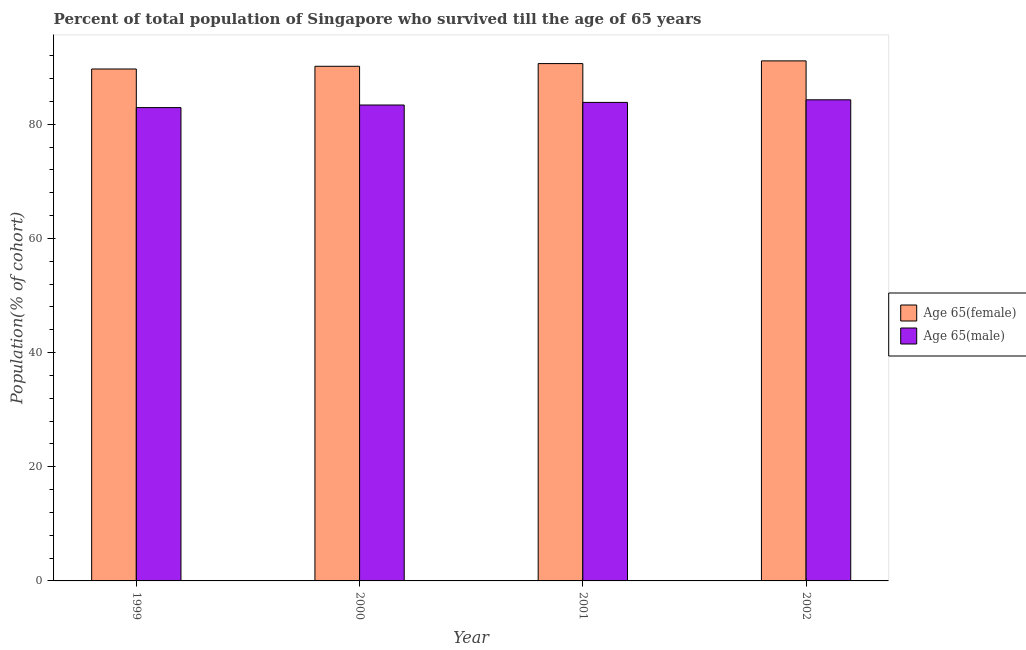How many different coloured bars are there?
Your answer should be very brief. 2. Are the number of bars on each tick of the X-axis equal?
Give a very brief answer. Yes. What is the label of the 3rd group of bars from the left?
Give a very brief answer. 2001. In how many cases, is the number of bars for a given year not equal to the number of legend labels?
Give a very brief answer. 0. What is the percentage of male population who survived till age of 65 in 2001?
Offer a terse response. 83.84. Across all years, what is the maximum percentage of female population who survived till age of 65?
Provide a short and direct response. 91.11. Across all years, what is the minimum percentage of male population who survived till age of 65?
Provide a succinct answer. 82.93. In which year was the percentage of male population who survived till age of 65 maximum?
Keep it short and to the point. 2002. What is the total percentage of female population who survived till age of 65 in the graph?
Offer a very short reply. 361.6. What is the difference between the percentage of female population who survived till age of 65 in 2001 and that in 2002?
Your answer should be very brief. -0.47. What is the difference between the percentage of male population who survived till age of 65 in 2001 and the percentage of female population who survived till age of 65 in 2002?
Your answer should be compact. -0.45. What is the average percentage of male population who survived till age of 65 per year?
Offer a terse response. 83.61. What is the ratio of the percentage of male population who survived till age of 65 in 1999 to that in 2000?
Offer a very short reply. 0.99. Is the difference between the percentage of female population who survived till age of 65 in 1999 and 2000 greater than the difference between the percentage of male population who survived till age of 65 in 1999 and 2000?
Your answer should be compact. No. What is the difference between the highest and the second highest percentage of male population who survived till age of 65?
Give a very brief answer. 0.45. What is the difference between the highest and the lowest percentage of female population who survived till age of 65?
Give a very brief answer. 1.42. What does the 1st bar from the left in 2001 represents?
Your answer should be compact. Age 65(female). What does the 2nd bar from the right in 2002 represents?
Offer a very short reply. Age 65(female). How many bars are there?
Your answer should be compact. 8. How many years are there in the graph?
Your answer should be very brief. 4. Does the graph contain any zero values?
Your answer should be very brief. No. How many legend labels are there?
Your response must be concise. 2. What is the title of the graph?
Provide a succinct answer. Percent of total population of Singapore who survived till the age of 65 years. Does "Travel Items" appear as one of the legend labels in the graph?
Your answer should be very brief. No. What is the label or title of the Y-axis?
Ensure brevity in your answer.  Population(% of cohort). What is the Population(% of cohort) in Age 65(female) in 1999?
Provide a succinct answer. 89.69. What is the Population(% of cohort) of Age 65(male) in 1999?
Make the answer very short. 82.93. What is the Population(% of cohort) in Age 65(female) in 2000?
Offer a terse response. 90.16. What is the Population(% of cohort) of Age 65(male) in 2000?
Your answer should be very brief. 83.38. What is the Population(% of cohort) of Age 65(female) in 2001?
Your response must be concise. 90.64. What is the Population(% of cohort) in Age 65(male) in 2001?
Offer a very short reply. 83.84. What is the Population(% of cohort) of Age 65(female) in 2002?
Offer a terse response. 91.11. What is the Population(% of cohort) of Age 65(male) in 2002?
Provide a succinct answer. 84.29. Across all years, what is the maximum Population(% of cohort) of Age 65(female)?
Offer a very short reply. 91.11. Across all years, what is the maximum Population(% of cohort) in Age 65(male)?
Your response must be concise. 84.29. Across all years, what is the minimum Population(% of cohort) in Age 65(female)?
Make the answer very short. 89.69. Across all years, what is the minimum Population(% of cohort) of Age 65(male)?
Your answer should be very brief. 82.93. What is the total Population(% of cohort) of Age 65(female) in the graph?
Offer a terse response. 361.6. What is the total Population(% of cohort) of Age 65(male) in the graph?
Your response must be concise. 334.43. What is the difference between the Population(% of cohort) of Age 65(female) in 1999 and that in 2000?
Keep it short and to the point. -0.47. What is the difference between the Population(% of cohort) in Age 65(male) in 1999 and that in 2000?
Your answer should be very brief. -0.45. What is the difference between the Population(% of cohort) in Age 65(female) in 1999 and that in 2001?
Your answer should be compact. -0.95. What is the difference between the Population(% of cohort) in Age 65(male) in 1999 and that in 2001?
Offer a terse response. -0.91. What is the difference between the Population(% of cohort) in Age 65(female) in 1999 and that in 2002?
Keep it short and to the point. -1.42. What is the difference between the Population(% of cohort) in Age 65(male) in 1999 and that in 2002?
Your answer should be compact. -1.36. What is the difference between the Population(% of cohort) in Age 65(female) in 2000 and that in 2001?
Ensure brevity in your answer.  -0.47. What is the difference between the Population(% of cohort) of Age 65(male) in 2000 and that in 2001?
Your answer should be compact. -0.45. What is the difference between the Population(% of cohort) of Age 65(female) in 2000 and that in 2002?
Give a very brief answer. -0.95. What is the difference between the Population(% of cohort) in Age 65(male) in 2000 and that in 2002?
Your answer should be very brief. -0.91. What is the difference between the Population(% of cohort) of Age 65(female) in 2001 and that in 2002?
Offer a terse response. -0.47. What is the difference between the Population(% of cohort) in Age 65(male) in 2001 and that in 2002?
Your response must be concise. -0.45. What is the difference between the Population(% of cohort) of Age 65(female) in 1999 and the Population(% of cohort) of Age 65(male) in 2000?
Offer a terse response. 6.31. What is the difference between the Population(% of cohort) of Age 65(female) in 1999 and the Population(% of cohort) of Age 65(male) in 2001?
Provide a succinct answer. 5.85. What is the difference between the Population(% of cohort) of Age 65(female) in 1999 and the Population(% of cohort) of Age 65(male) in 2002?
Keep it short and to the point. 5.4. What is the difference between the Population(% of cohort) of Age 65(female) in 2000 and the Population(% of cohort) of Age 65(male) in 2001?
Offer a terse response. 6.33. What is the difference between the Population(% of cohort) of Age 65(female) in 2000 and the Population(% of cohort) of Age 65(male) in 2002?
Provide a short and direct response. 5.87. What is the difference between the Population(% of cohort) in Age 65(female) in 2001 and the Population(% of cohort) in Age 65(male) in 2002?
Ensure brevity in your answer.  6.35. What is the average Population(% of cohort) of Age 65(female) per year?
Make the answer very short. 90.4. What is the average Population(% of cohort) of Age 65(male) per year?
Provide a succinct answer. 83.61. In the year 1999, what is the difference between the Population(% of cohort) in Age 65(female) and Population(% of cohort) in Age 65(male)?
Provide a short and direct response. 6.76. In the year 2000, what is the difference between the Population(% of cohort) in Age 65(female) and Population(% of cohort) in Age 65(male)?
Give a very brief answer. 6.78. In the year 2001, what is the difference between the Population(% of cohort) of Age 65(female) and Population(% of cohort) of Age 65(male)?
Keep it short and to the point. 6.8. In the year 2002, what is the difference between the Population(% of cohort) of Age 65(female) and Population(% of cohort) of Age 65(male)?
Your response must be concise. 6.82. What is the ratio of the Population(% of cohort) of Age 65(male) in 1999 to that in 2000?
Offer a very short reply. 0.99. What is the ratio of the Population(% of cohort) of Age 65(female) in 1999 to that in 2002?
Ensure brevity in your answer.  0.98. What is the ratio of the Population(% of cohort) of Age 65(male) in 1999 to that in 2002?
Offer a very short reply. 0.98. What is the ratio of the Population(% of cohort) in Age 65(female) in 2000 to that in 2001?
Make the answer very short. 0.99. What is the ratio of the Population(% of cohort) in Age 65(female) in 2000 to that in 2002?
Your answer should be very brief. 0.99. What is the difference between the highest and the second highest Population(% of cohort) of Age 65(female)?
Provide a succinct answer. 0.47. What is the difference between the highest and the second highest Population(% of cohort) of Age 65(male)?
Offer a terse response. 0.45. What is the difference between the highest and the lowest Population(% of cohort) in Age 65(female)?
Provide a short and direct response. 1.42. What is the difference between the highest and the lowest Population(% of cohort) in Age 65(male)?
Provide a short and direct response. 1.36. 